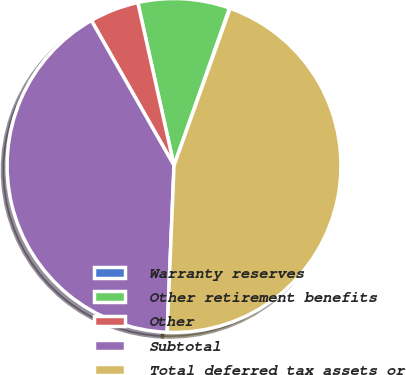Convert chart to OTSL. <chart><loc_0><loc_0><loc_500><loc_500><pie_chart><fcel>Warranty reserves<fcel>Other retirement benefits<fcel>Other<fcel>Subtotal<fcel>Total deferred tax assets or<nl><fcel>0.07%<fcel>8.87%<fcel>4.76%<fcel>41.1%<fcel>45.2%<nl></chart> 